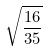Convert formula to latex. <formula><loc_0><loc_0><loc_500><loc_500>\sqrt { \frac { 1 6 } { 3 5 } }</formula> 